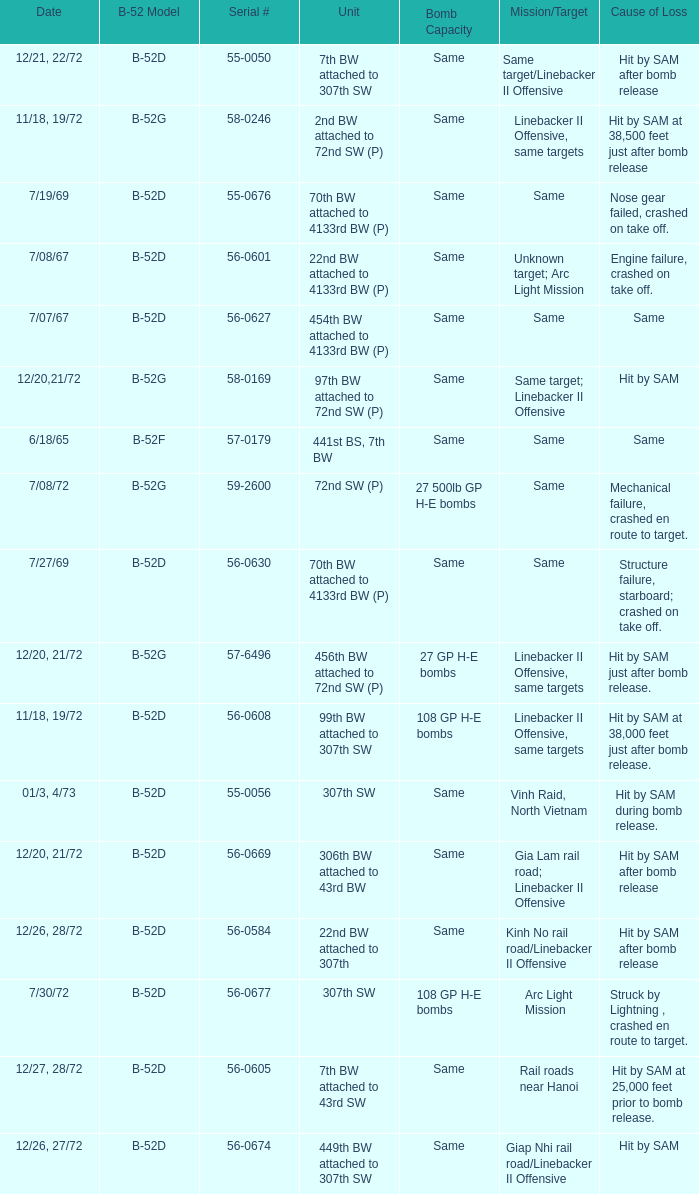When  same target; linebacker ii offensive is the same target what is the unit? 97th BW attached to 72nd SW (P). 